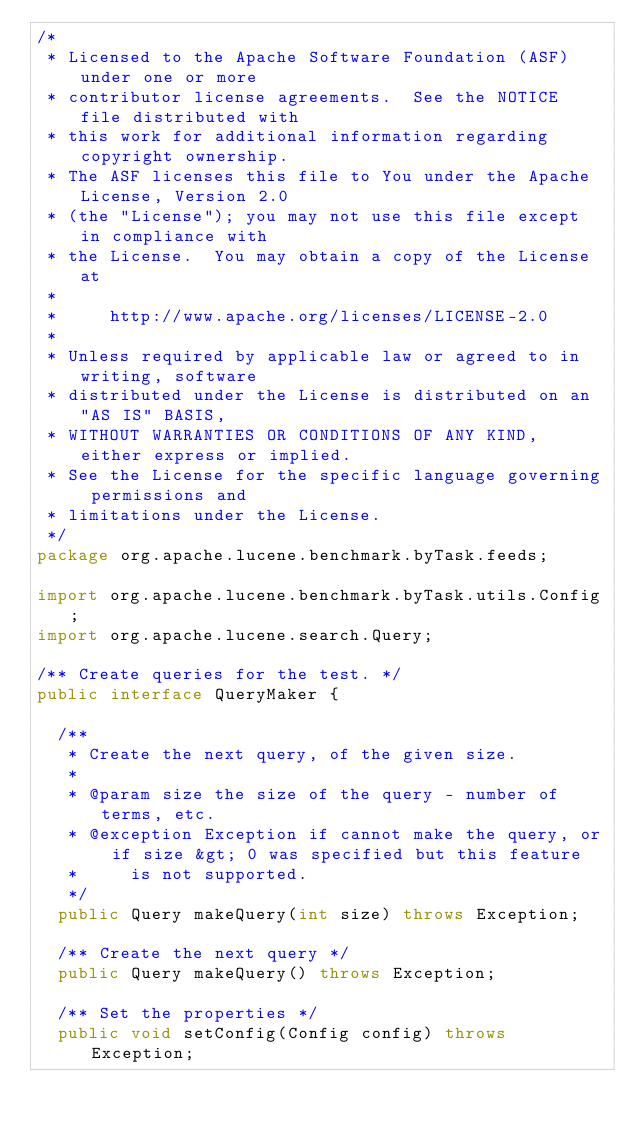<code> <loc_0><loc_0><loc_500><loc_500><_Java_>/*
 * Licensed to the Apache Software Foundation (ASF) under one or more
 * contributor license agreements.  See the NOTICE file distributed with
 * this work for additional information regarding copyright ownership.
 * The ASF licenses this file to You under the Apache License, Version 2.0
 * (the "License"); you may not use this file except in compliance with
 * the License.  You may obtain a copy of the License at
 *
 *     http://www.apache.org/licenses/LICENSE-2.0
 *
 * Unless required by applicable law or agreed to in writing, software
 * distributed under the License is distributed on an "AS IS" BASIS,
 * WITHOUT WARRANTIES OR CONDITIONS OF ANY KIND, either express or implied.
 * See the License for the specific language governing permissions and
 * limitations under the License.
 */
package org.apache.lucene.benchmark.byTask.feeds;

import org.apache.lucene.benchmark.byTask.utils.Config;
import org.apache.lucene.search.Query;

/** Create queries for the test. */
public interface QueryMaker {

  /**
   * Create the next query, of the given size.
   *
   * @param size the size of the query - number of terms, etc.
   * @exception Exception if cannot make the query, or if size &gt; 0 was specified but this feature
   *     is not supported.
   */
  public Query makeQuery(int size) throws Exception;

  /** Create the next query */
  public Query makeQuery() throws Exception;

  /** Set the properties */
  public void setConfig(Config config) throws Exception;
</code> 